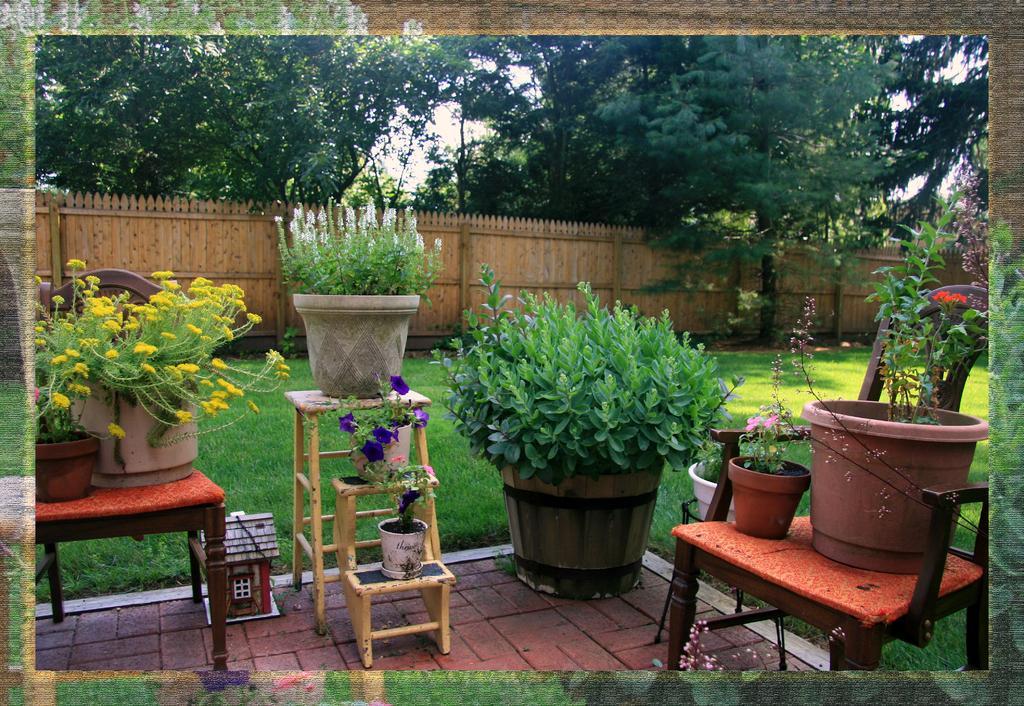Please provide a concise description of this image. In this image I can see many flower pots. At the back there's a wall. In the background there are trees and the sky. 